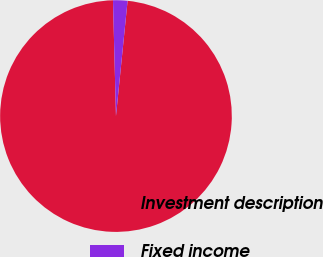Convert chart. <chart><loc_0><loc_0><loc_500><loc_500><pie_chart><fcel>Investment description<fcel>Fixed income<nl><fcel>97.99%<fcel>2.01%<nl></chart> 